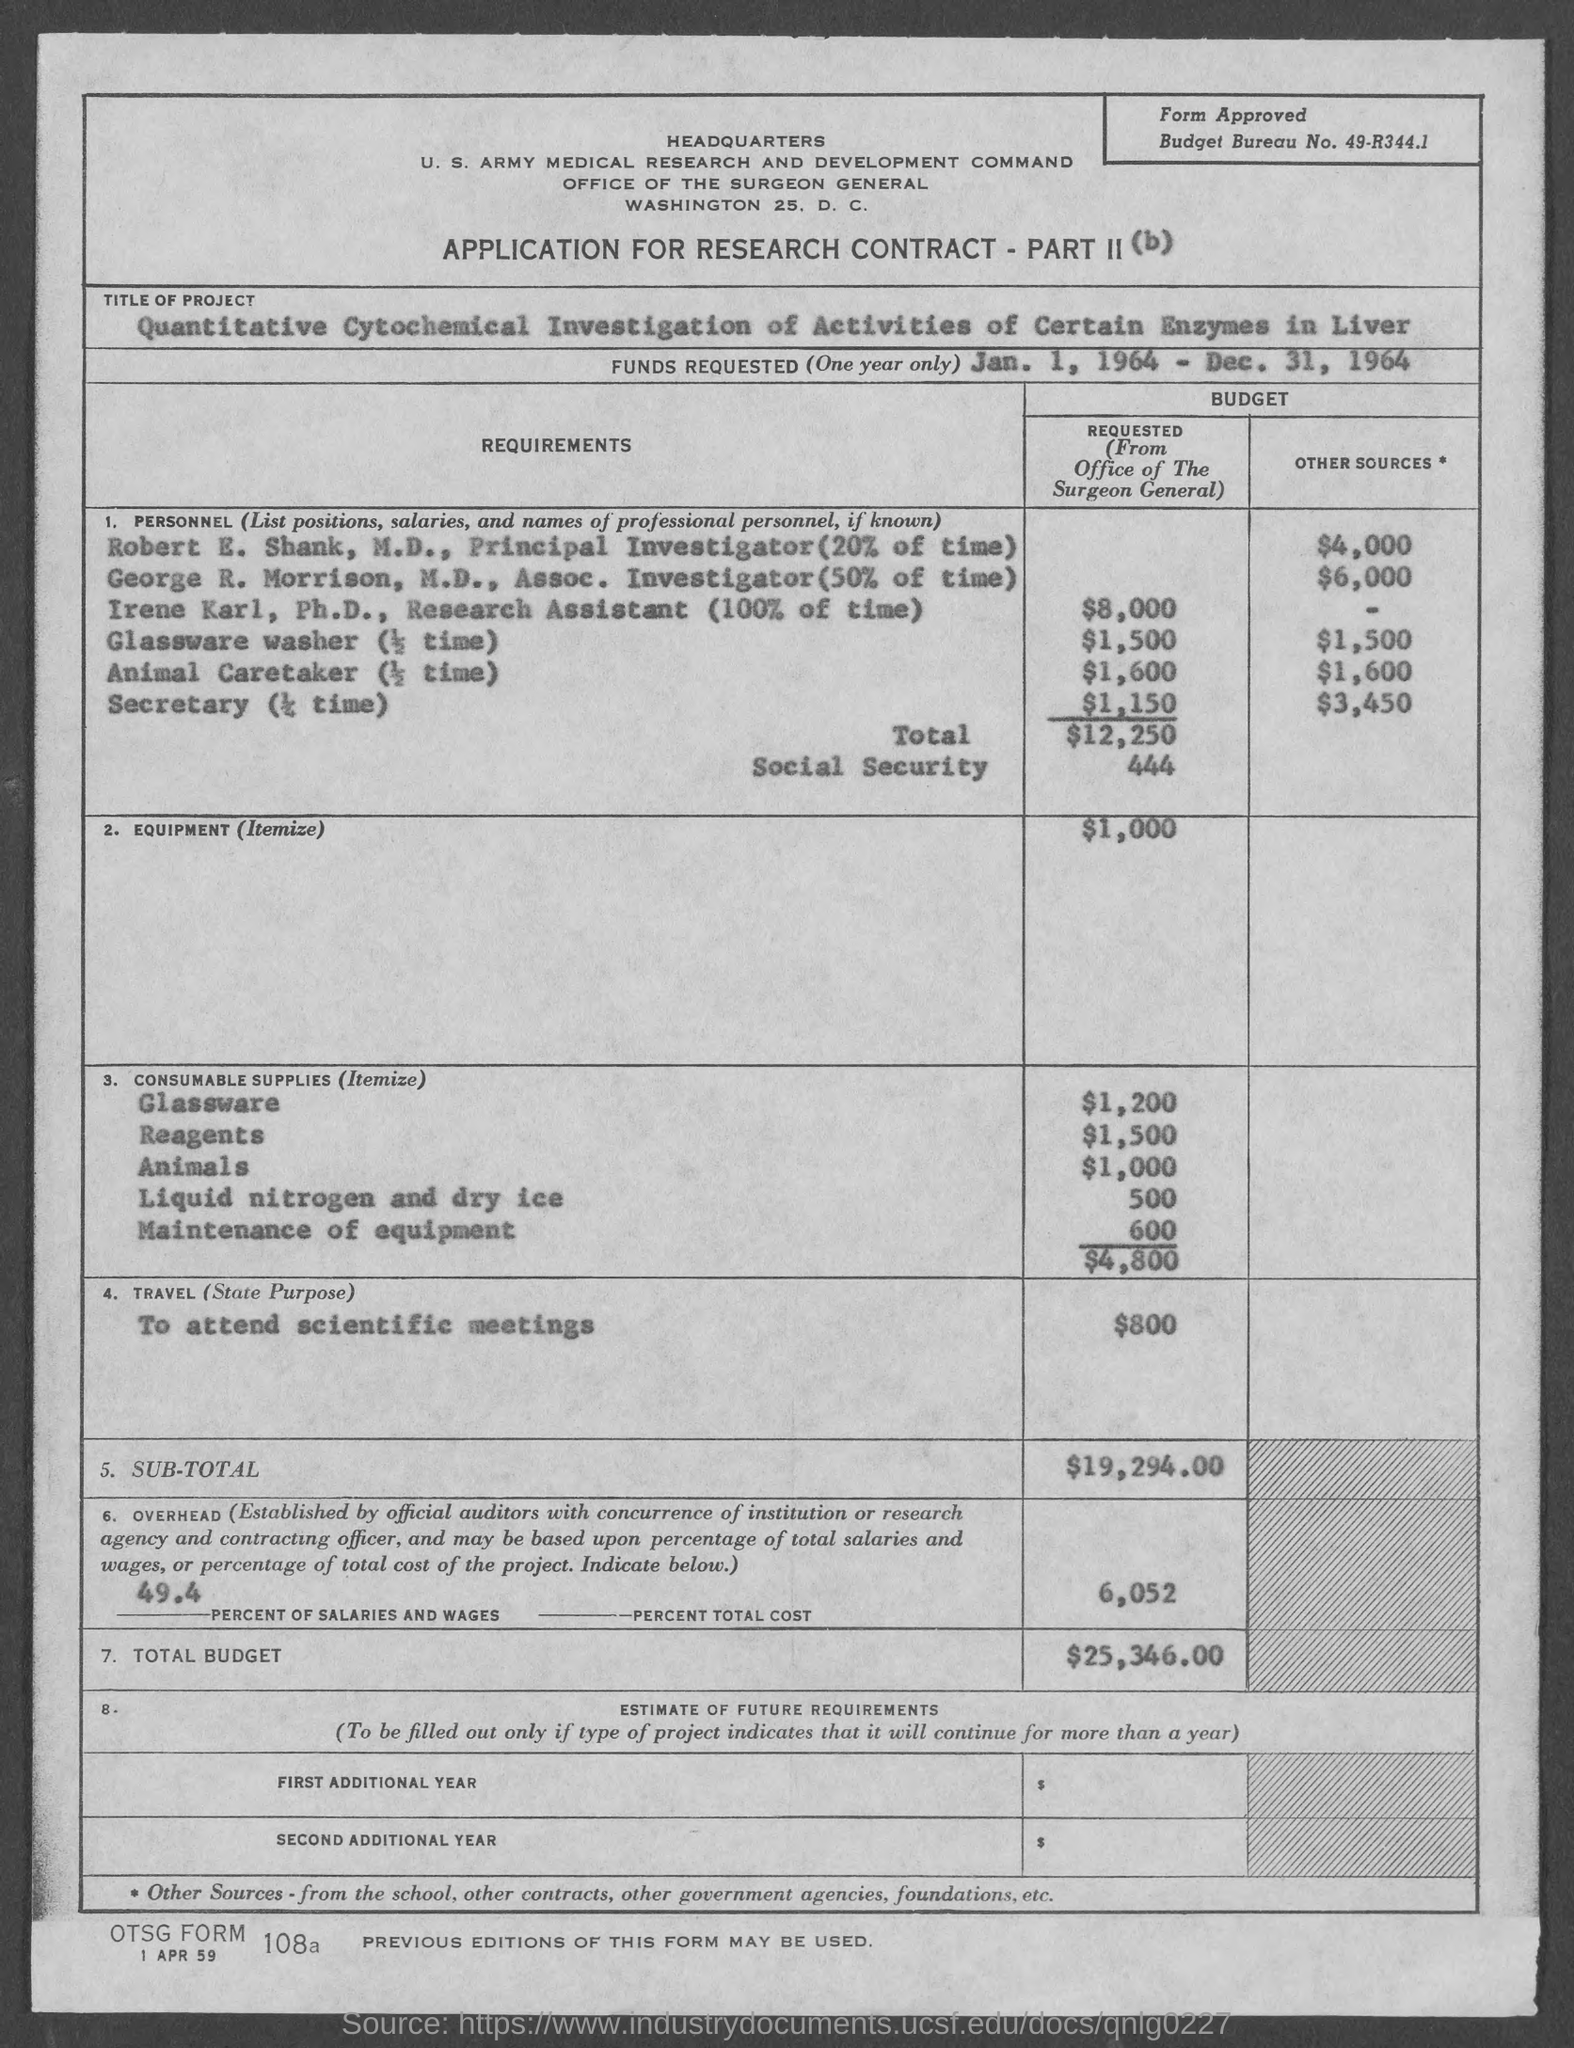What is the budget bureau no.?
Your answer should be very brief. 49-R344.1. 